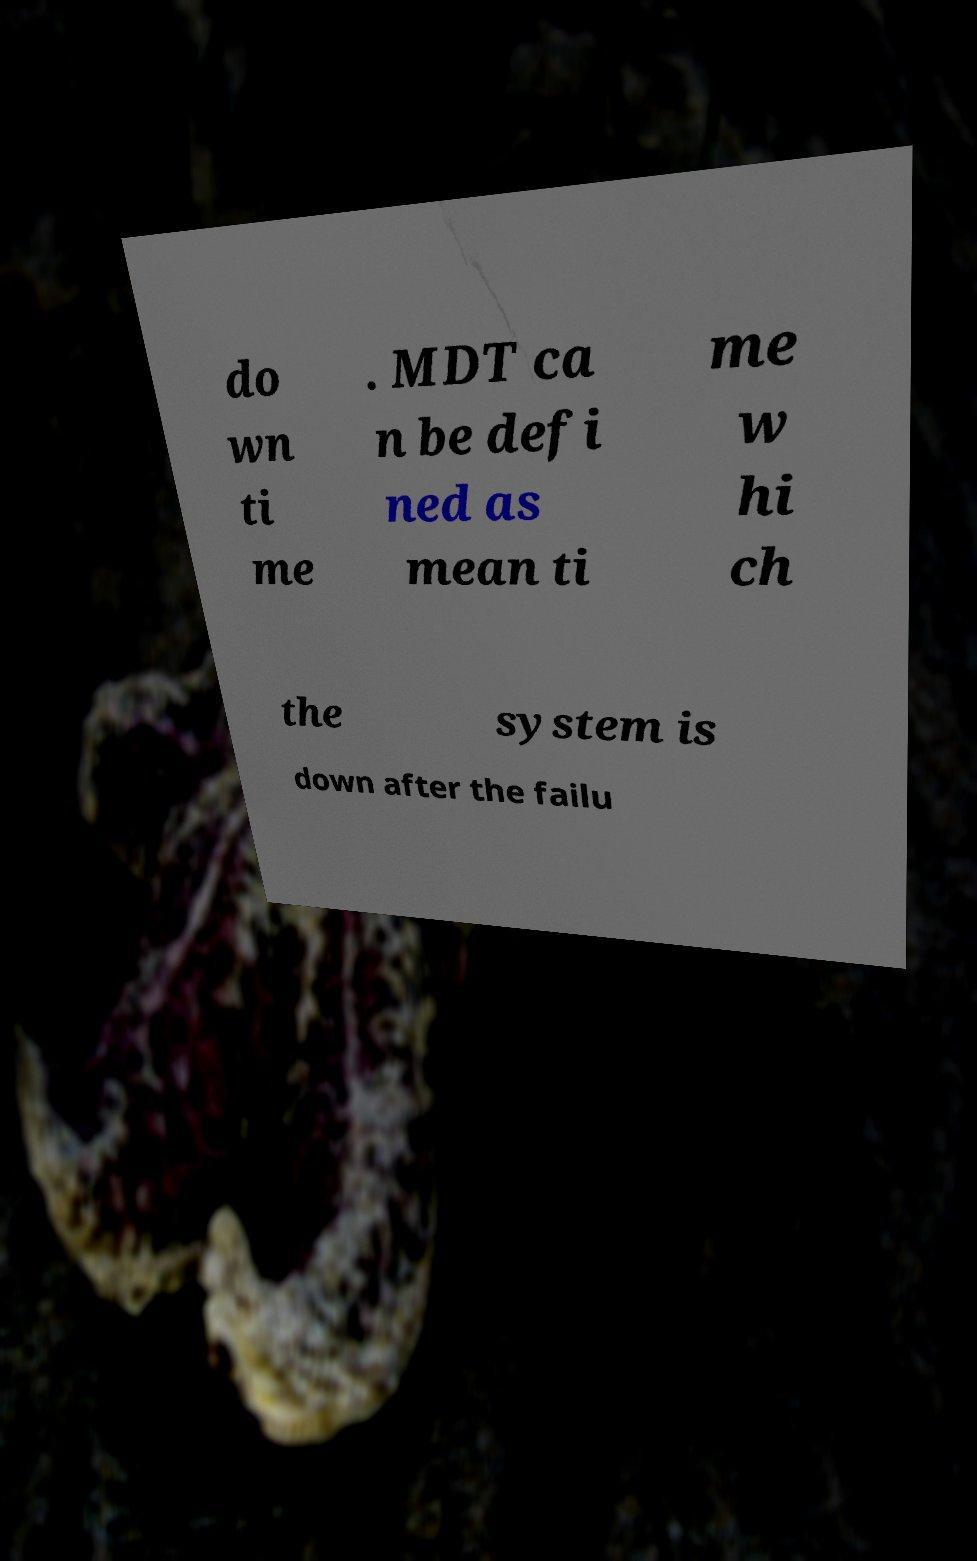Can you read and provide the text displayed in the image?This photo seems to have some interesting text. Can you extract and type it out for me? do wn ti me . MDT ca n be defi ned as mean ti me w hi ch the system is down after the failu 